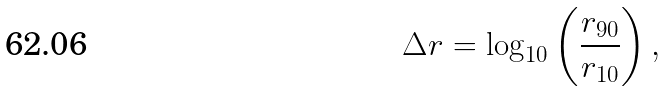Convert formula to latex. <formula><loc_0><loc_0><loc_500><loc_500>\Delta r = \log _ { 1 0 } \left ( \frac { r _ { 9 0 } } { r _ { 1 0 } } \right ) ,</formula> 